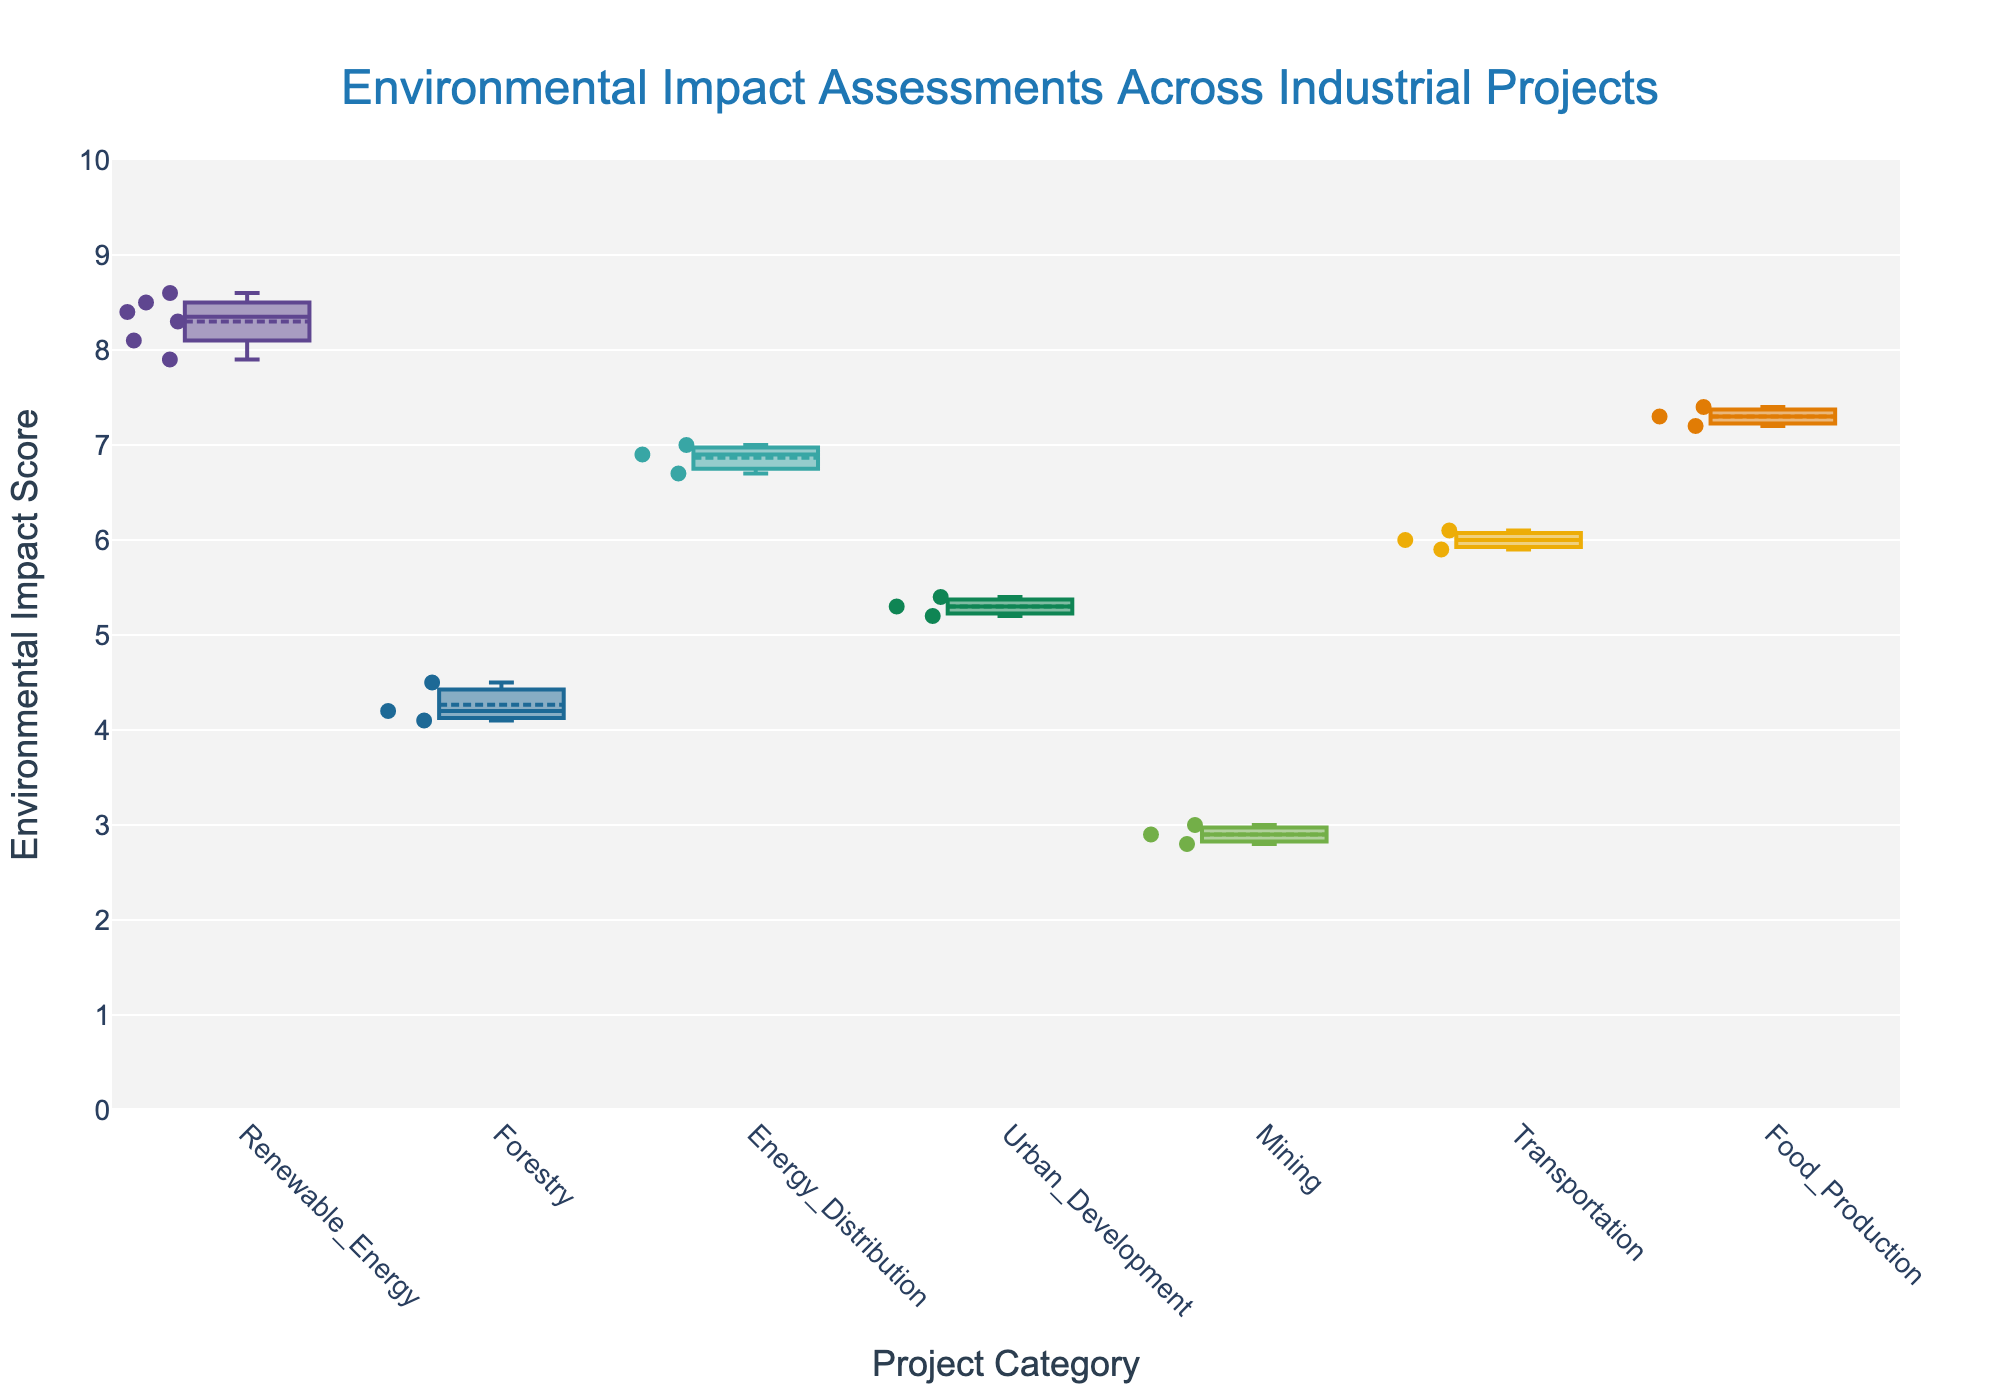What's the title of the figure? The title of the figure is displayed at the top in a larger font size. It reads "Environmental Impact Assessments Across Industrial Projects." This title describes the content of the plot.
Answer: Environmental Impact Assessments Across Industrial Projects What does the y-axis represent? The label on the y-axis indicates that it represents "Environmental Impact Score," which shows the impact scores of various industrial projects.
Answer: Environmental Impact Score How many unique categories of projects are there in the figure? By examining the different box plots, we can count the number of unique categories. There are 7 categories: Renewable Energy, Forestry, Energy Distribution, Urban Development, Mining, Transportation, and Food Production.
Answer: 7 Which category has the lowest median environmental impact score? Each box plot includes a line representing the median. By comparing these lines, we can see that Mining, with a median close to 2.9, has the lowest median score.
Answer: Mining What is the range of scores for the Renewable Energy category? The Renewable Energy category includes both "Offshore Wind Farm" and "Hydroelectric Dam" projects. By examining the whiskers of these box plots, we see the scores range from approximately 7.9 to 8.6.
Answer: 7.9 to 8.6 Which project category has the highest upper whisker value? The upper whisker is the furthest point above the box, excluding outliers. Renewable Energy has the highest upper whisker value, indicating an upper limit around 8.6.
Answer: Renewable Energy Are there any outliers in the dataset? If so, in which categories? Outliers are data points that fall outside the whiskers of the box plots. By examining the box plots closely, we see no points that lie significantly outside the whisker ranges.
Answer: No outliers What is the median environmental impact score for the Urban Development category? The median is indicated by the line inside the box. For Urban Development, this line is around 5.3.
Answer: 5.3 Which category has the smallest interquartile range (IQR) and what is it? The IQR is the range between the first quartile (bottom of the box) and the third quartile (top of the box). By observing the sizes of the boxes, we can see Renewable Energy has the smallest IQR, ranging from approximately 8.0 to 8.4, giving an IQR of about 0.4.
Answer: Renewable Energy, 0.4 How do the median scores of the Forestry and Transportation categories compare? Looking at the median lines within the boxes, Forestry has a median score around 4.5, while Transportation has a median score around 6.0. Therefore, Transportation has a higher median compared to Forestry.
Answer: Transportation is higher 